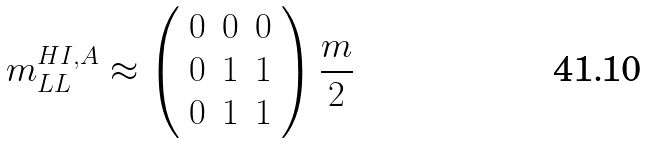Convert formula to latex. <formula><loc_0><loc_0><loc_500><loc_500>m _ { L L } ^ { H I , A } \approx \left ( \begin{array} { c c c } 0 & 0 & 0 \\ 0 & 1 & 1 \\ 0 & 1 & 1 \end{array} \right ) \frac { m } { 2 }</formula> 